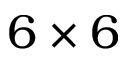<formula> <loc_0><loc_0><loc_500><loc_500>6 \times 6</formula> 